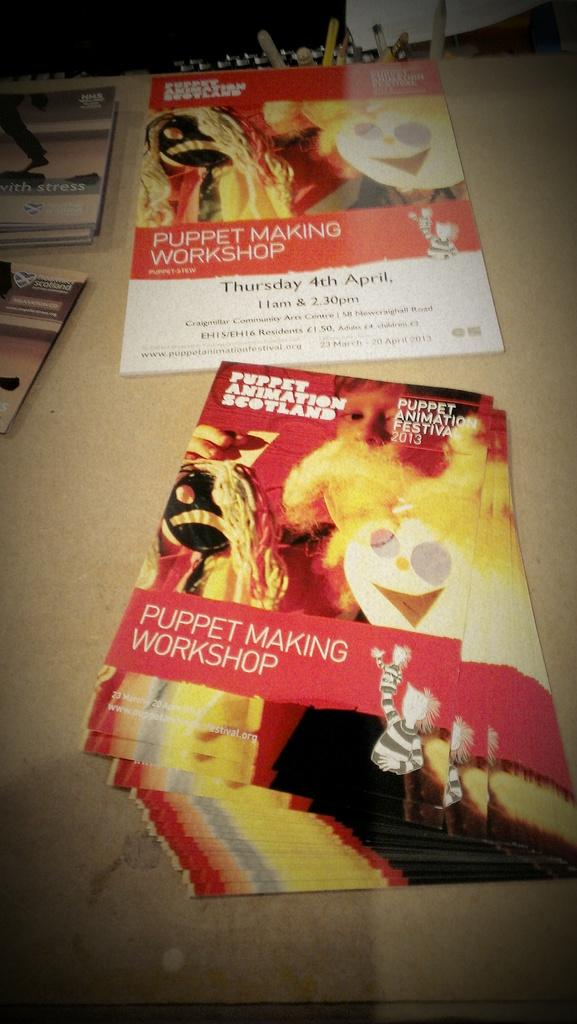What piece of furniture is present in the image? There is a table in the image. What is placed on the table? There are pamphlets on the table. What type of content is included in the pamphlets? The pamphlets contain text and cartoon images. What type of religion is being practiced in the image? There is no indication of any religious practice in the image; it only features a table with pamphlets containing text and cartoon images. How many apples are visible in the image? There are no apples present in the image. 